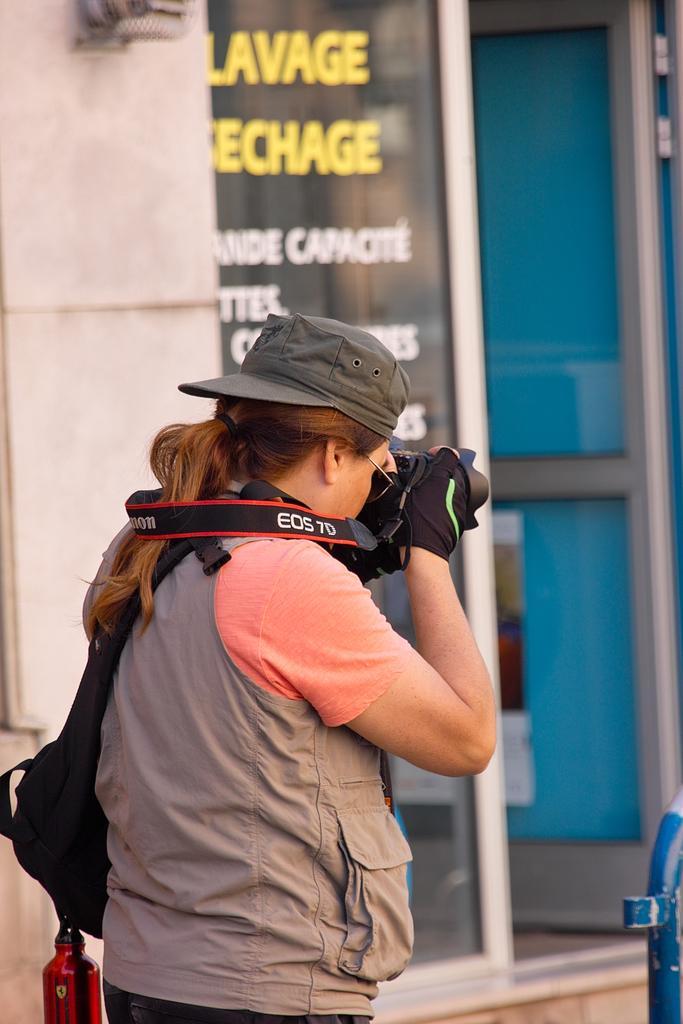How would you summarize this image in a sentence or two? In this picture we can see door, poster, pillar and objects. We can see a woman wearing a cap and goggles. She is holding a camera and looks like she is taking a snap. 